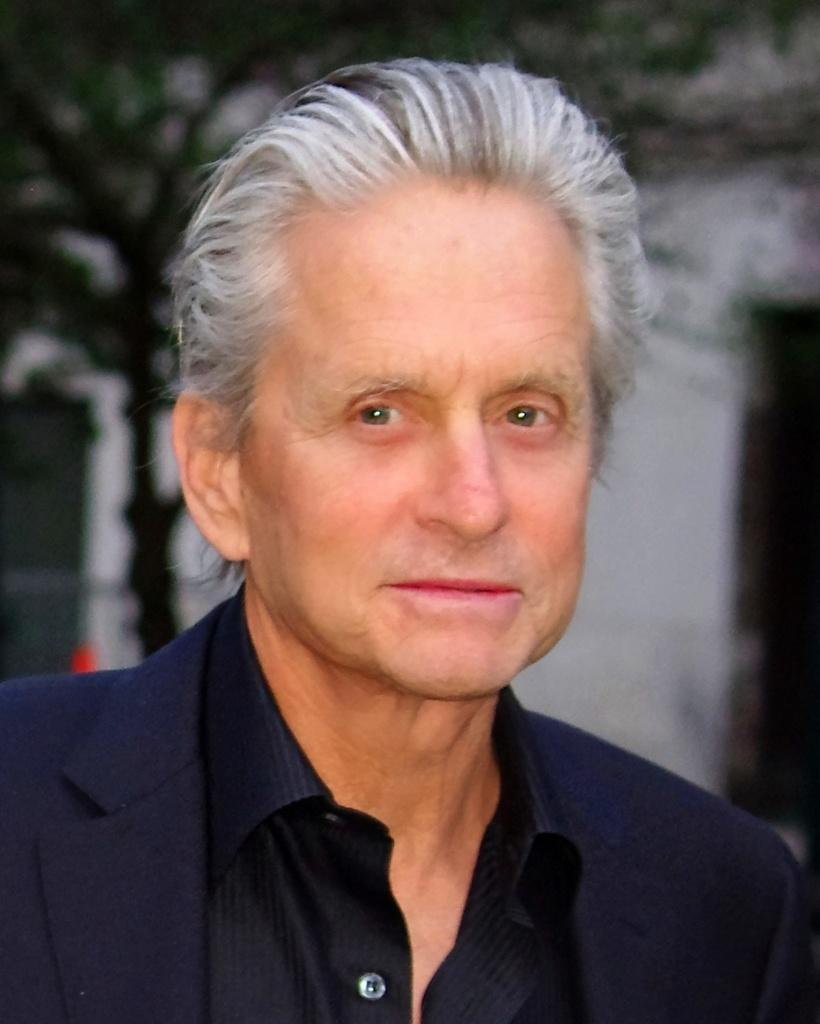What is the main subject of the image? The main subject of the image is a man. What is the man wearing in the image? The man is wearing a blue suit and a black shirt. What is the man's facial expression in the image? The man is smiling in the image. What is the man doing in the image? The man is giving a pose for the picture. What can be seen in the background of the image? There is a tree and a wall in the background of the image. How many cows are visible in the image? There are no cows present in the image. What type of string is the man holding in the image? There is no string visible in the image. 